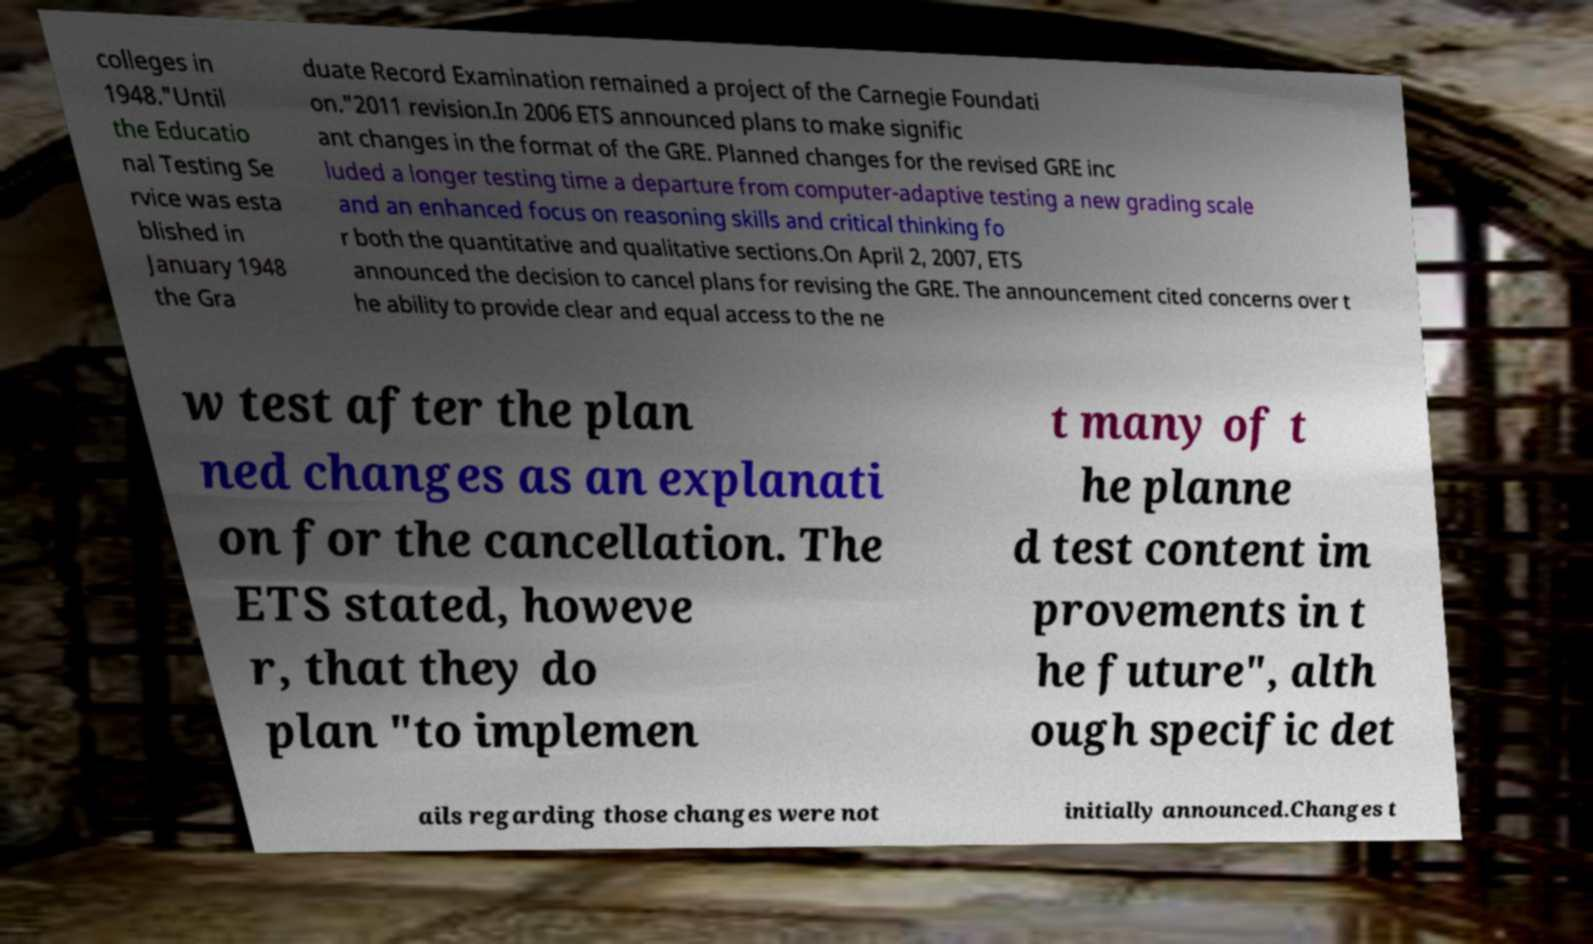Can you read and provide the text displayed in the image?This photo seems to have some interesting text. Can you extract and type it out for me? colleges in 1948."Until the Educatio nal Testing Se rvice was esta blished in January 1948 the Gra duate Record Examination remained a project of the Carnegie Foundati on."2011 revision.In 2006 ETS announced plans to make signific ant changes in the format of the GRE. Planned changes for the revised GRE inc luded a longer testing time a departure from computer-adaptive testing a new grading scale and an enhanced focus on reasoning skills and critical thinking fo r both the quantitative and qualitative sections.On April 2, 2007, ETS announced the decision to cancel plans for revising the GRE. The announcement cited concerns over t he ability to provide clear and equal access to the ne w test after the plan ned changes as an explanati on for the cancellation. The ETS stated, howeve r, that they do plan "to implemen t many of t he planne d test content im provements in t he future", alth ough specific det ails regarding those changes were not initially announced.Changes t 